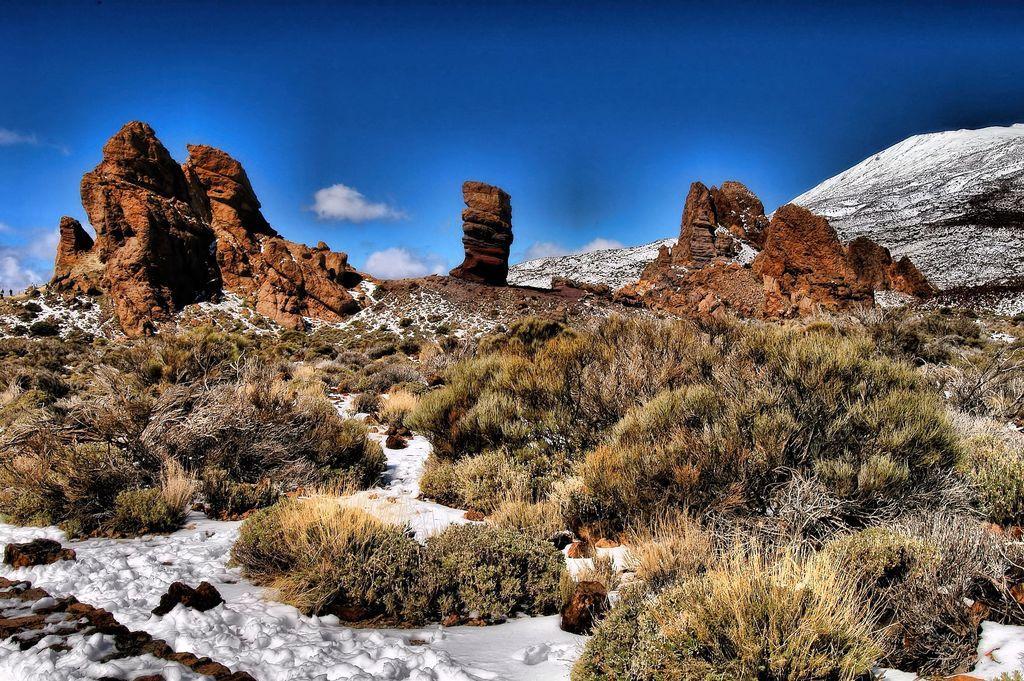How would you summarize this image in a sentence or two? In this image we can see snow, grass, stones and mountains, in the background, we can see the sky with clouds. 